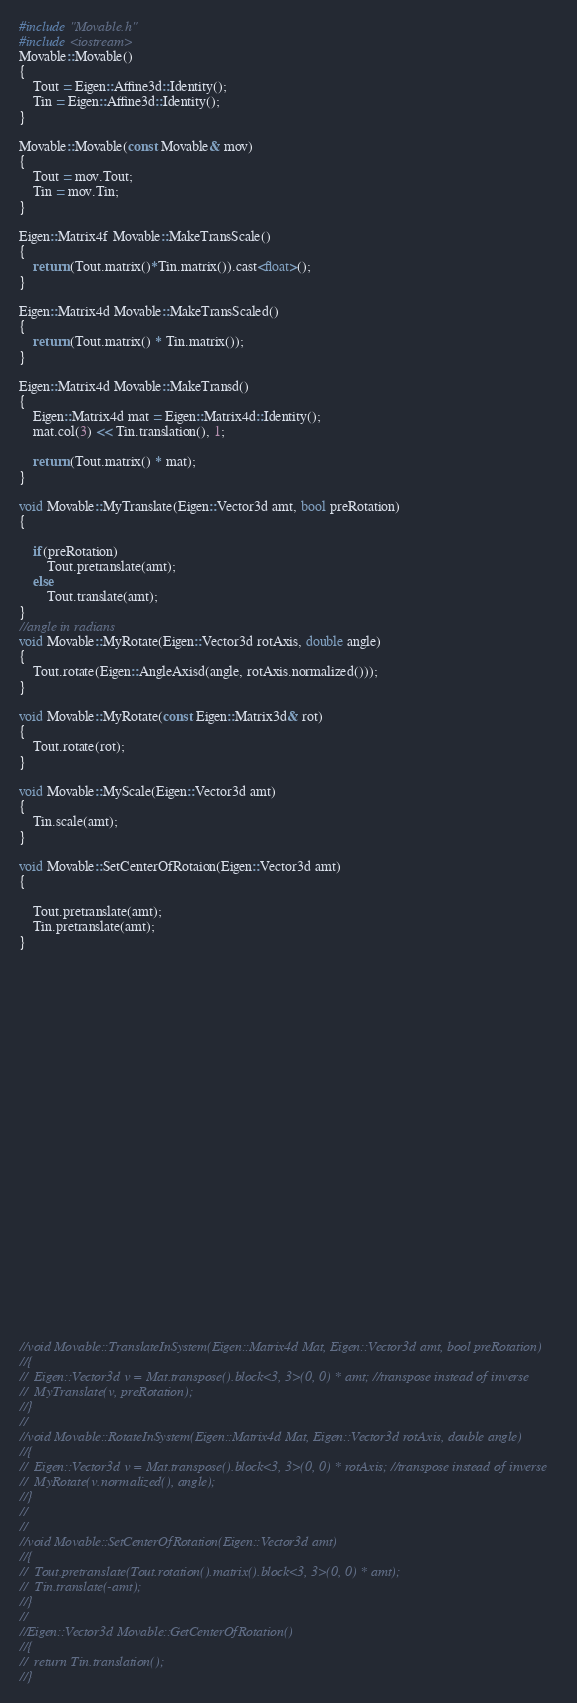Convert code to text. <code><loc_0><loc_0><loc_500><loc_500><_C++_>#include "Movable.h"
#include <iostream>
Movable::Movable()
{
	Tout = Eigen::Affine3d::Identity();
	Tin = Eigen::Affine3d::Identity();
}

Movable::Movable(const Movable& mov)
{
	Tout = mov.Tout;
	Tin = mov.Tin;
}

Eigen::Matrix4f Movable::MakeTransScale()
{
	return (Tout.matrix()*Tin.matrix()).cast<float>();
}

Eigen::Matrix4d Movable::MakeTransScaled()
{
	return (Tout.matrix() * Tin.matrix());
}

Eigen::Matrix4d Movable::MakeTransd()
{
	Eigen::Matrix4d mat = Eigen::Matrix4d::Identity();
	mat.col(3) << Tin.translation(), 1;

	return (Tout.matrix() * mat);
}

void Movable::MyTranslate(Eigen::Vector3d amt, bool preRotation)
{
	
	if(preRotation)
		Tout.pretranslate(amt);
	else
		Tout.translate(amt);
}
//angle in radians
void Movable::MyRotate(Eigen::Vector3d rotAxis, double angle)
{
	Tout.rotate(Eigen::AngleAxisd(angle, rotAxis.normalized()));
}

void Movable::MyRotate(const Eigen::Matrix3d& rot)
{
	Tout.rotate(rot);
}

void Movable::MyScale(Eigen::Vector3d amt)
{
	Tin.scale(amt);
}

void Movable::SetCenterOfRotaion(Eigen::Vector3d amt)
{

	Tout.pretranslate(amt);
	Tin.pretranslate(amt);
}


























//void Movable::TranslateInSystem(Eigen::Matrix4d Mat, Eigen::Vector3d amt, bool preRotation)
//{
//	Eigen::Vector3d v = Mat.transpose().block<3, 3>(0, 0) * amt; //transpose instead of inverse
//	MyTranslate(v, preRotation);
//}
//
//void Movable::RotateInSystem(Eigen::Matrix4d Mat, Eigen::Vector3d rotAxis, double angle)
//{
//	Eigen::Vector3d v = Mat.transpose().block<3, 3>(0, 0) * rotAxis; //transpose instead of inverse
//	MyRotate(v.normalized(), angle);
//}
//
//
//void Movable::SetCenterOfRotation(Eigen::Vector3d amt)
//{
//	Tout.pretranslate(Tout.rotation().matrix().block<3, 3>(0, 0) * amt);
//	Tin.translate(-amt);
//}
//
//Eigen::Vector3d Movable::GetCenterOfRotation()
//{
//	return Tin.translation();
//}
</code> 